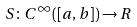Convert formula to latex. <formula><loc_0><loc_0><loc_500><loc_500>S \colon C ^ { \infty } ( [ a , b ] ) \rightarrow R</formula> 